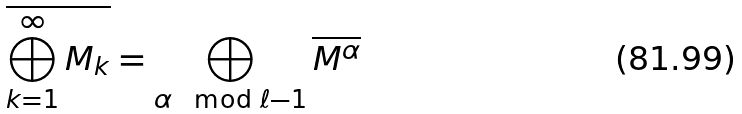Convert formula to latex. <formula><loc_0><loc_0><loc_500><loc_500>\overline { \bigoplus _ { k = 1 } ^ { \infty } M _ { k } } = \bigoplus _ { \alpha \mod { \ell - 1 } } \overline { M ^ { \alpha } }</formula> 